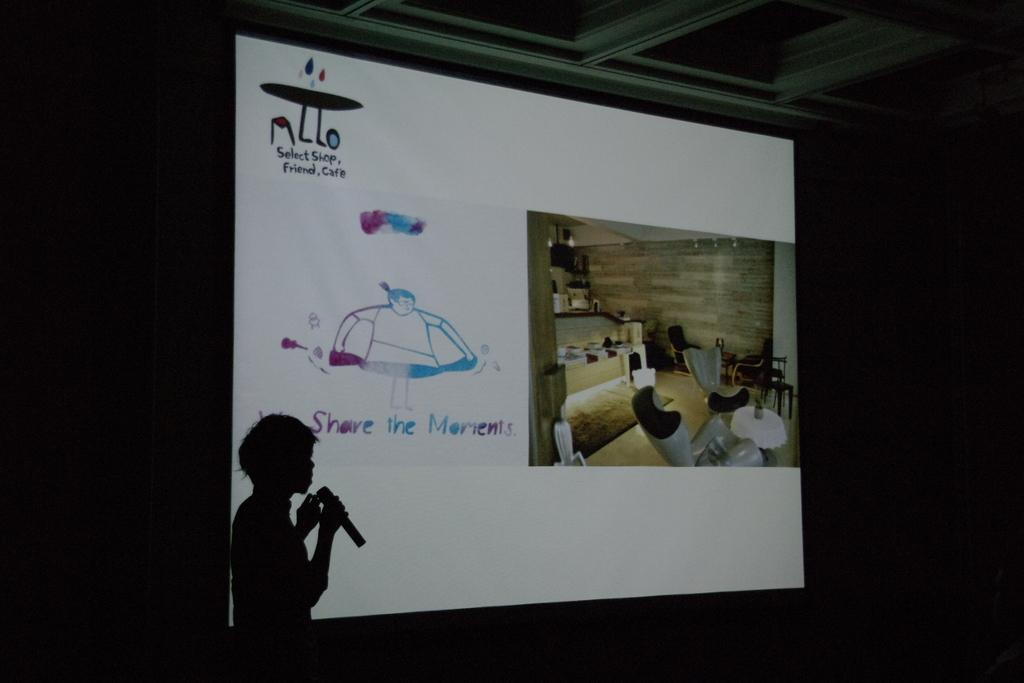What is the main object in the center of the image? There is a projector screen in the center of the picture. What can be seen on the left side of the image? There is a person's shadow holding a mic on the left side of the image. How would you describe the lighting in the image? The sides of the picture are dark. What part of the room can be seen at the top of the image? The ceiling is visible at the top of the image. What type of disgust can be seen on the person's face in the image? There is no person present in the image, only a person's shadow holding a mic. How many legs are visible in the image? There are no visible legs in the image, only a person's shadow holding a mic. 